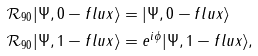Convert formula to latex. <formula><loc_0><loc_0><loc_500><loc_500>\mathcal { R } _ { 9 0 } | \Psi , 0 - f l u x \rangle & = | \Psi , 0 - f l u x \rangle \\ \mathcal { R } _ { 9 0 } | \Psi , 1 - f l u x \rangle & = e ^ { i \phi } | \Psi , 1 - f l u x \rangle ,</formula> 